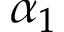Convert formula to latex. <formula><loc_0><loc_0><loc_500><loc_500>\alpha _ { 1 }</formula> 